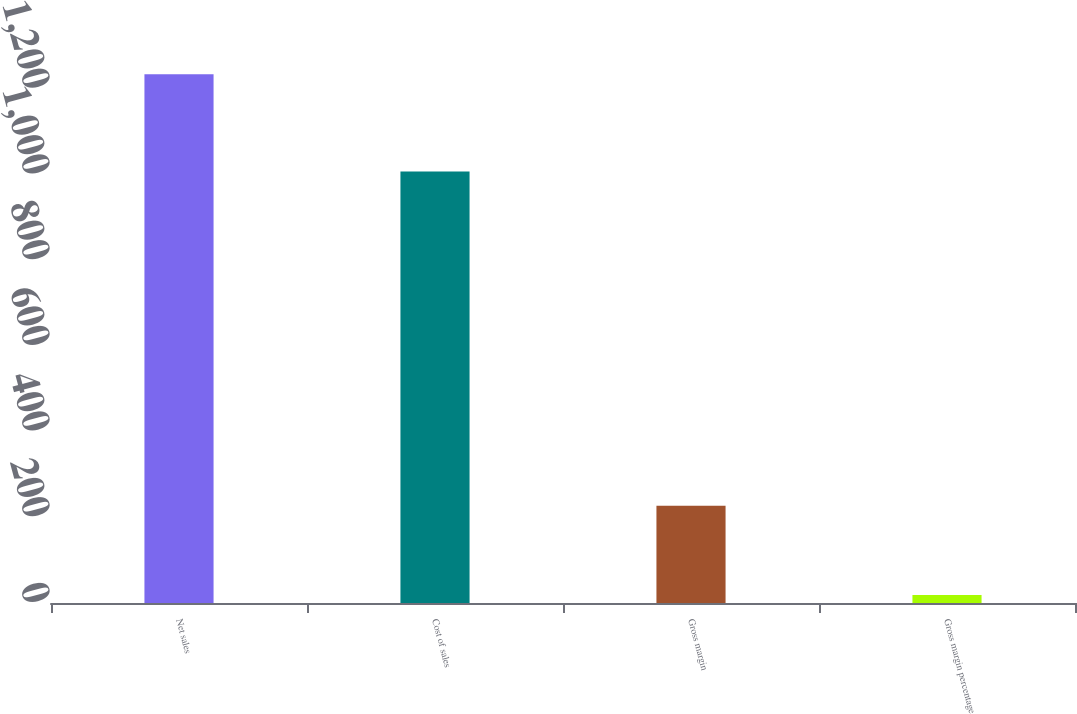Convert chart. <chart><loc_0><loc_0><loc_500><loc_500><bar_chart><fcel>Net sales<fcel>Cost of sales<fcel>Gross margin<fcel>Gross margin percentage<nl><fcel>1234<fcel>1007<fcel>227<fcel>18.4<nl></chart> 